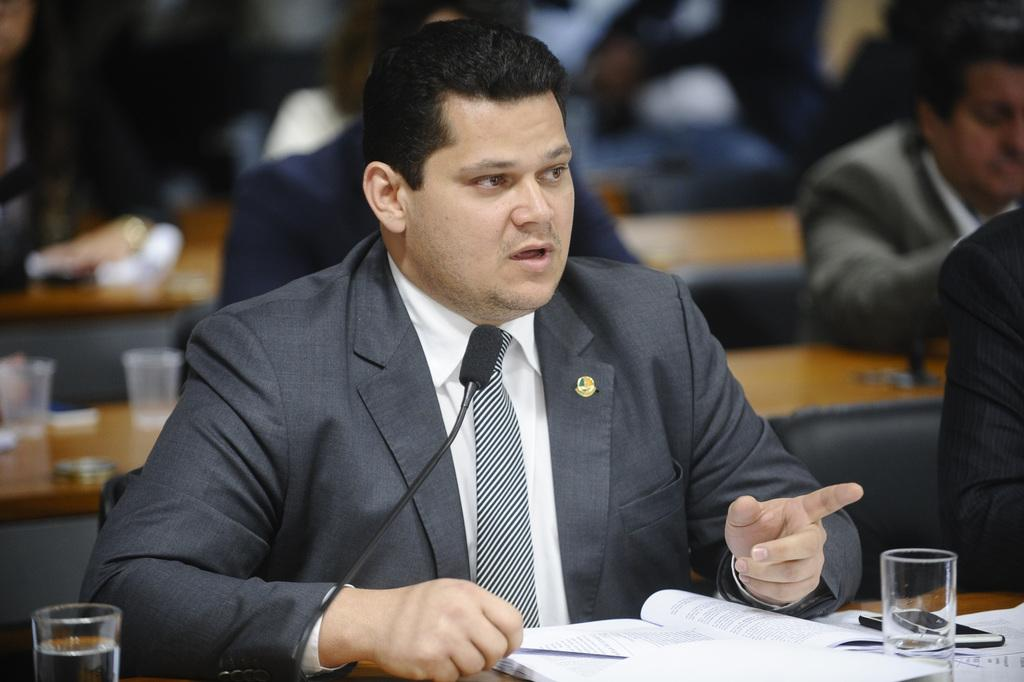How many people are in the image? There is a group of people in the image, but the exact number is not specified. What are the people doing in the image? The people are sitting in front of tables. What items can be seen on the tables? There are papers, glasses, mobile phones, and microphones on the tables. Can you see a boat in the image? No, there is no boat present in the image. What type of wind instrument is being played by the people in the image? There is no wind instrument or any indication of music being played in the image. 